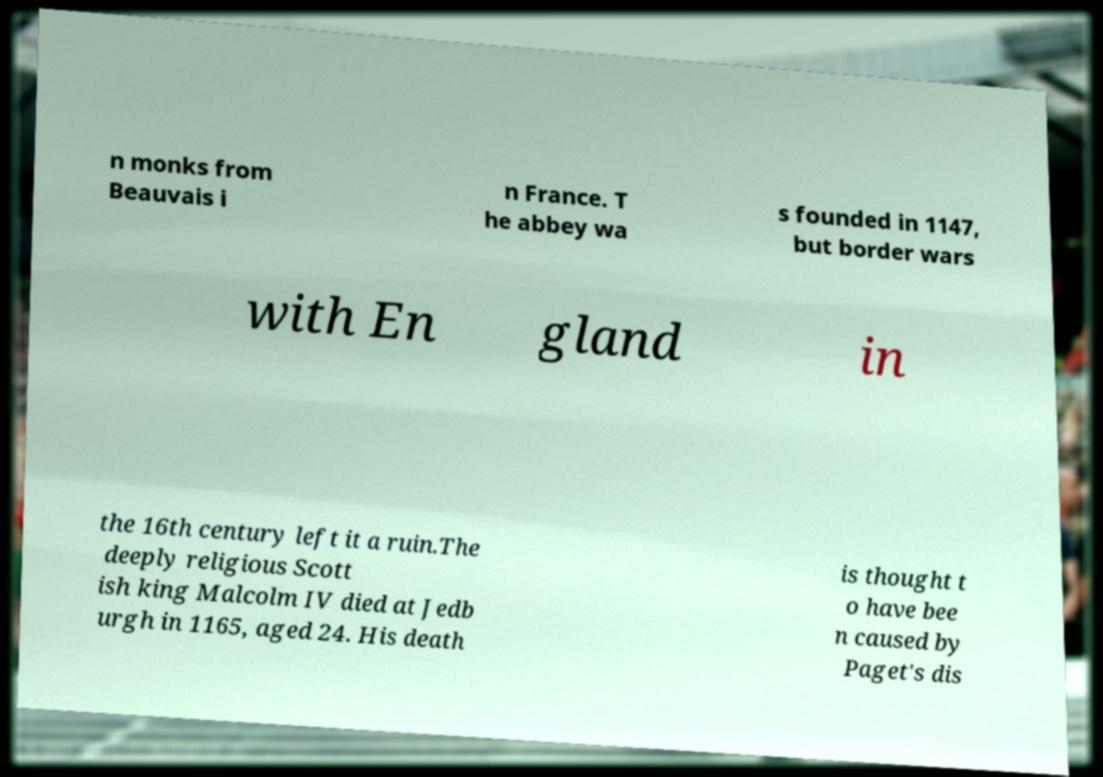Can you read and provide the text displayed in the image?This photo seems to have some interesting text. Can you extract and type it out for me? n monks from Beauvais i n France. T he abbey wa s founded in 1147, but border wars with En gland in the 16th century left it a ruin.The deeply religious Scott ish king Malcolm IV died at Jedb urgh in 1165, aged 24. His death is thought t o have bee n caused by Paget's dis 